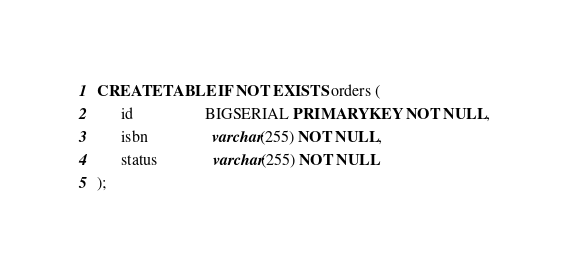<code> <loc_0><loc_0><loc_500><loc_500><_SQL_>CREATE TABLE IF NOT EXISTS orders (
      id                  BIGSERIAL PRIMARY KEY NOT NULL,
      isbn                varchar(255) NOT NULL,
      status              varchar(255) NOT NULL
);</code> 